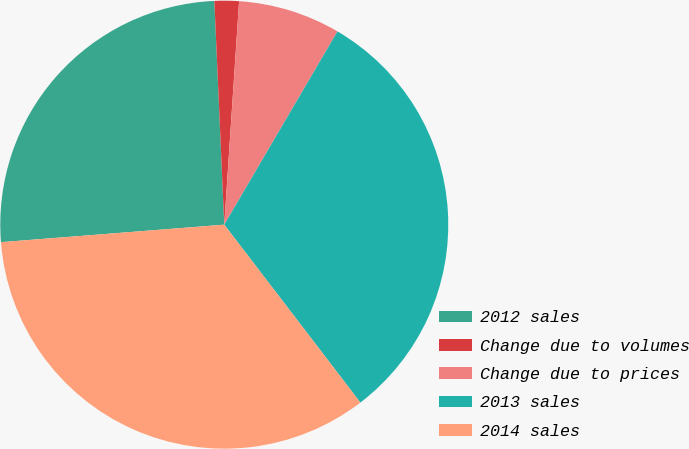<chart> <loc_0><loc_0><loc_500><loc_500><pie_chart><fcel>2012 sales<fcel>Change due to volumes<fcel>Change due to prices<fcel>2013 sales<fcel>2014 sales<nl><fcel>25.54%<fcel>1.76%<fcel>7.38%<fcel>31.17%<fcel>34.15%<nl></chart> 